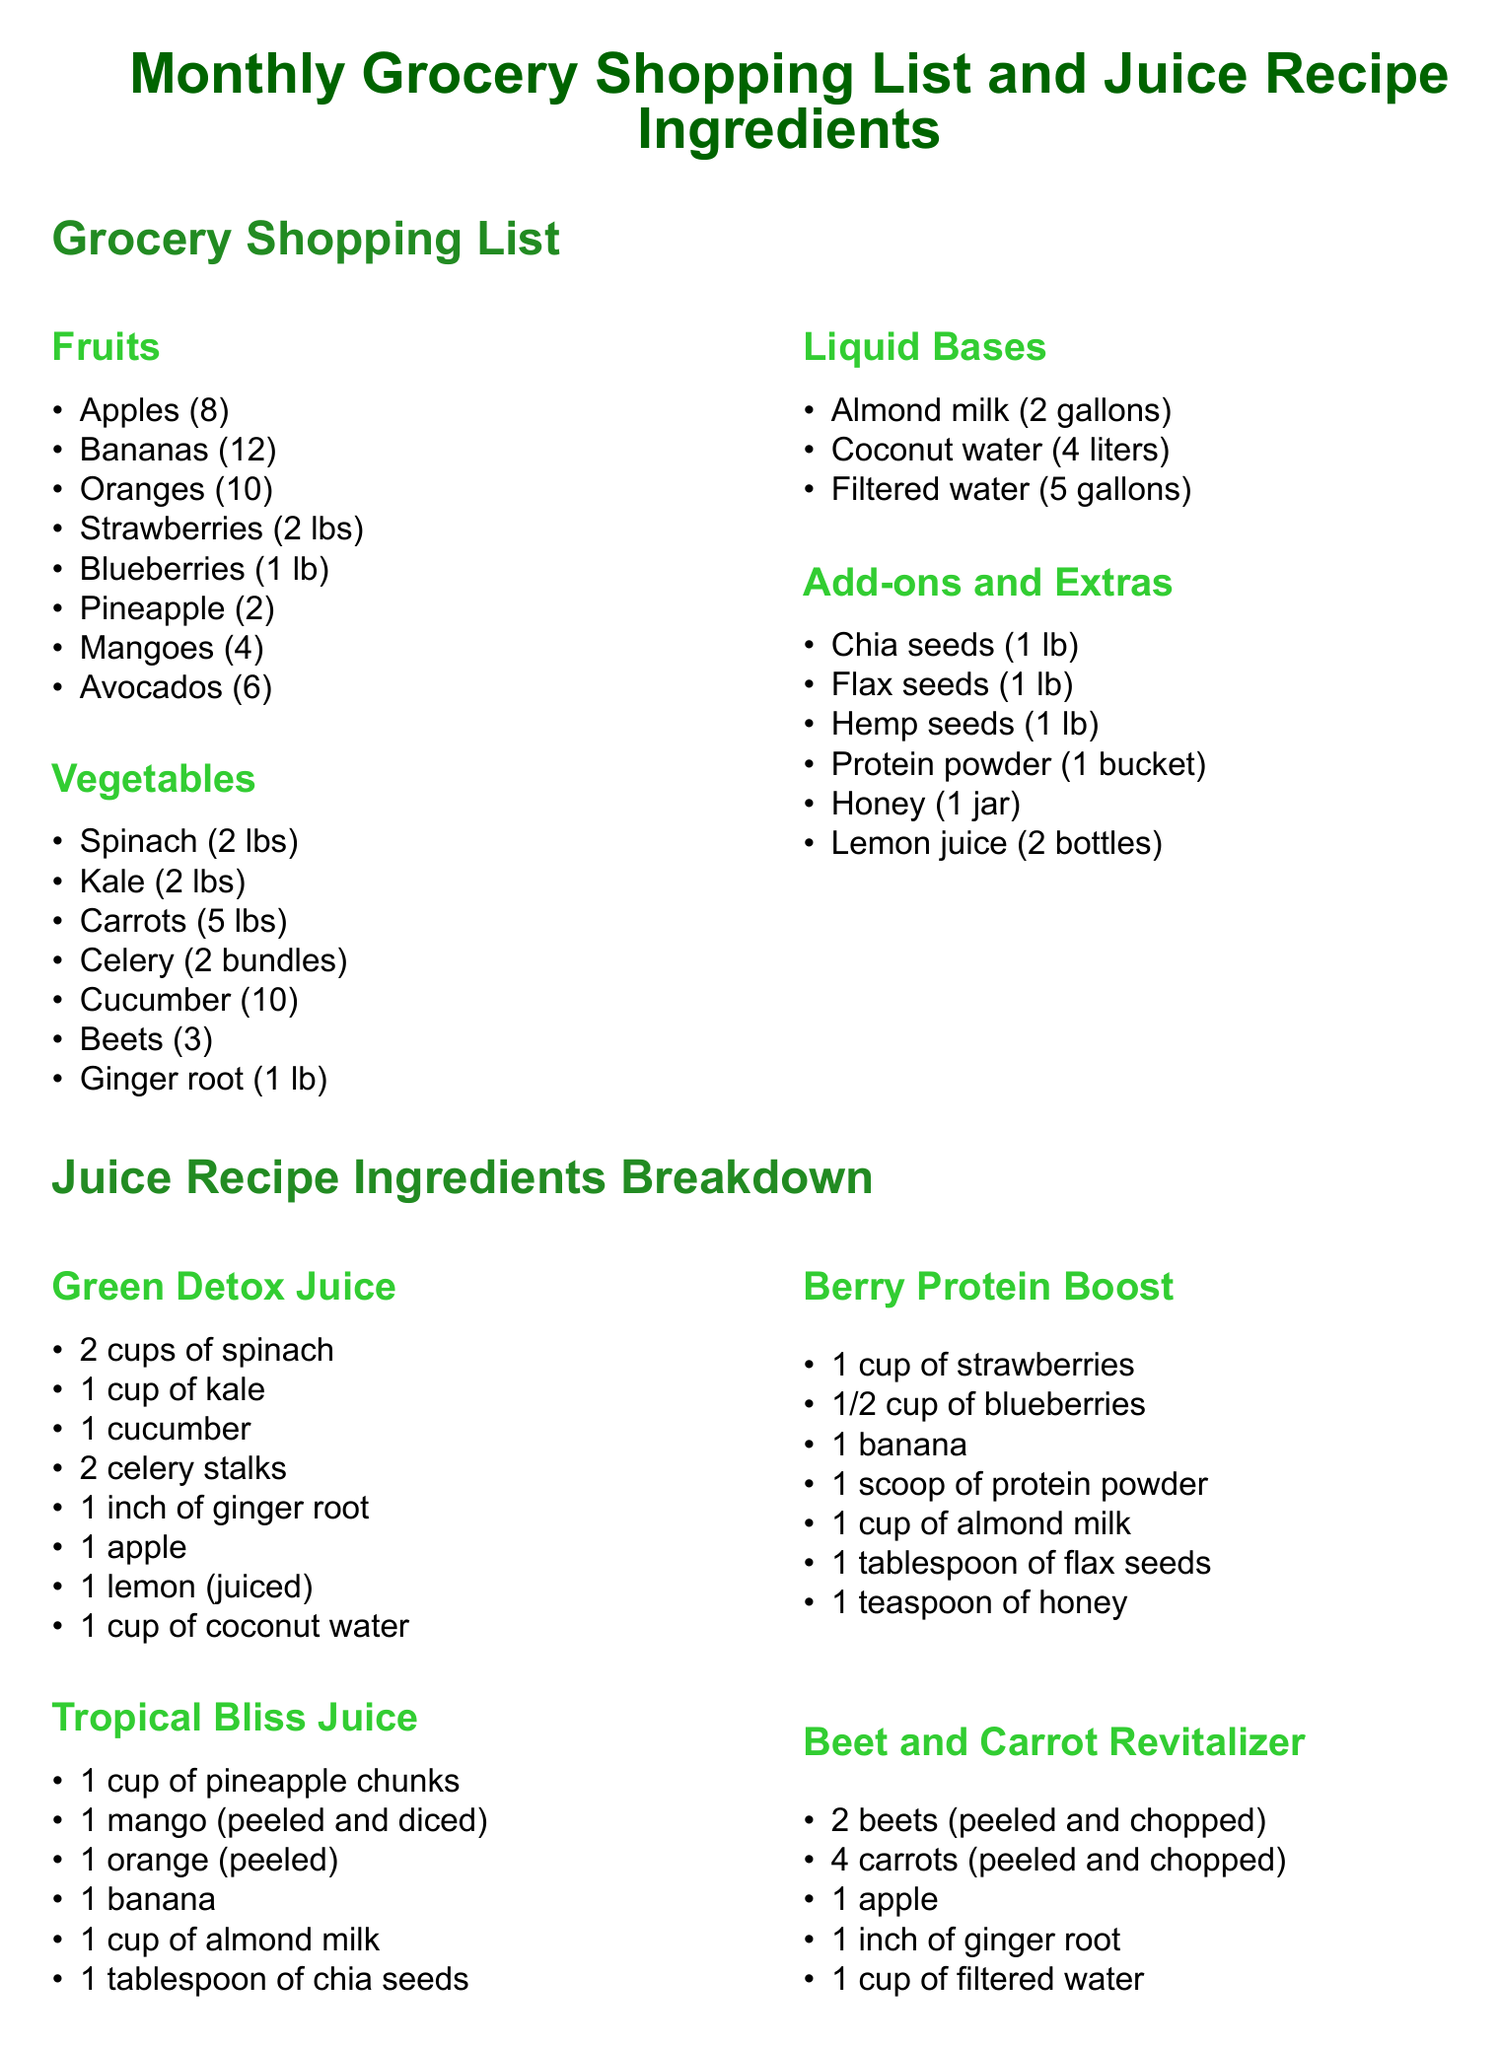What fruits are listed in the grocery shopping list? The fruits section in the grocery shopping list includes apples, bananas, oranges, strawberries, blueberries, pineapple, mangoes, and avocados.
Answer: apples, bananas, oranges, strawberries, blueberries, pineapple, mangoes, avocados How many apples are included in the grocery shopping list? The grocery shopping list specifies that 8 apples are included.
Answer: 8 What is the main liquid base used in Tropical Bliss Juice? The ingredients for Tropical Bliss Juice include 1 cup of almond milk as the liquid base.
Answer: almond milk Which juice recipe includes ginger root? Green Detox Juice and Beet and Carrot Revitalizer both list ginger root among their ingredients.
Answer: Green Detox Juice, Beet and Carrot Revitalizer How many types of vegetables are listed in the grocery shopping list? The vegetables section consists of spinach, kale, carrots, celery, cucumber, beets, and ginger root, which totals 7 types of vegetables.
Answer: 7 What is the total quantity of kale specified in the grocery shopping list? The grocery shopping list indicates that 2 lbs of kale are included.
Answer: 2 lbs Which juice contains the highest fruit diversity based on the ingredients? Tropical Bliss Juice contains a mix of pineapple, mango, orange, and banana.
Answer: Tropical Bliss Juice How many cups of strawberries are needed for the Berry Protein Boost recipe? The Berry Protein Boost recipe requires 1 cup of strawberries.
Answer: 1 cup 